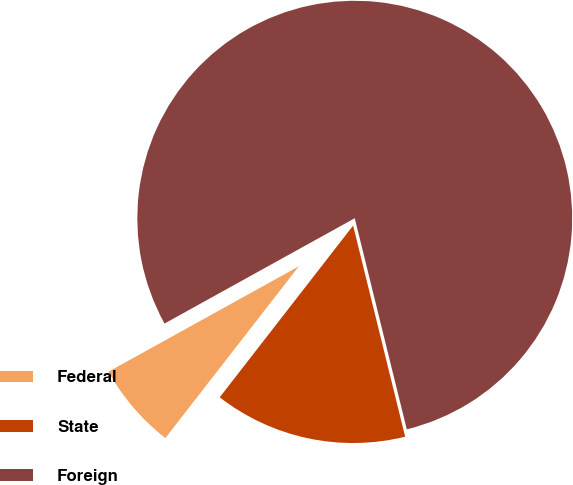Convert chart. <chart><loc_0><loc_0><loc_500><loc_500><pie_chart><fcel>Federal<fcel>State<fcel>Foreign<nl><fcel>6.44%<fcel>14.36%<fcel>79.2%<nl></chart> 